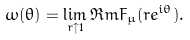<formula> <loc_0><loc_0><loc_500><loc_500>\omega ( \theta ) = \lim _ { r \uparrow 1 } \Re m F _ { \mu } ( r e ^ { i \theta } ) .</formula> 